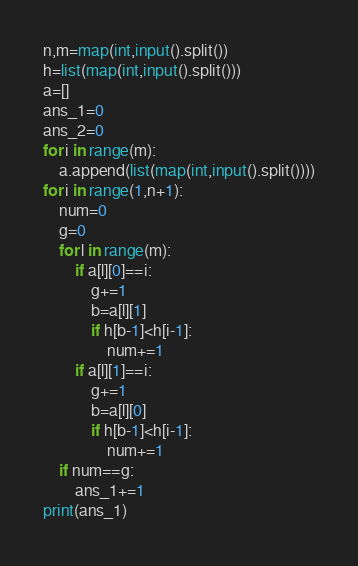Convert code to text. <code><loc_0><loc_0><loc_500><loc_500><_Python_>n,m=map(int,input().split())
h=list(map(int,input().split()))
a=[]
ans_1=0
ans_2=0
for i in range(m):
    a.append(list(map(int,input().split())))
for i in range(1,n+1):
    num=0
    g=0
    for l in range(m):
        if a[l][0]==i:
            g+=1
            b=a[l][1]
            if h[b-1]<h[i-1]:
                num+=1
        if a[l][1]==i:
            g+=1
            b=a[l][0]
            if h[b-1]<h[i-1]:
                num+=1
    if num==g:
        ans_1+=1
print(ans_1)</code> 